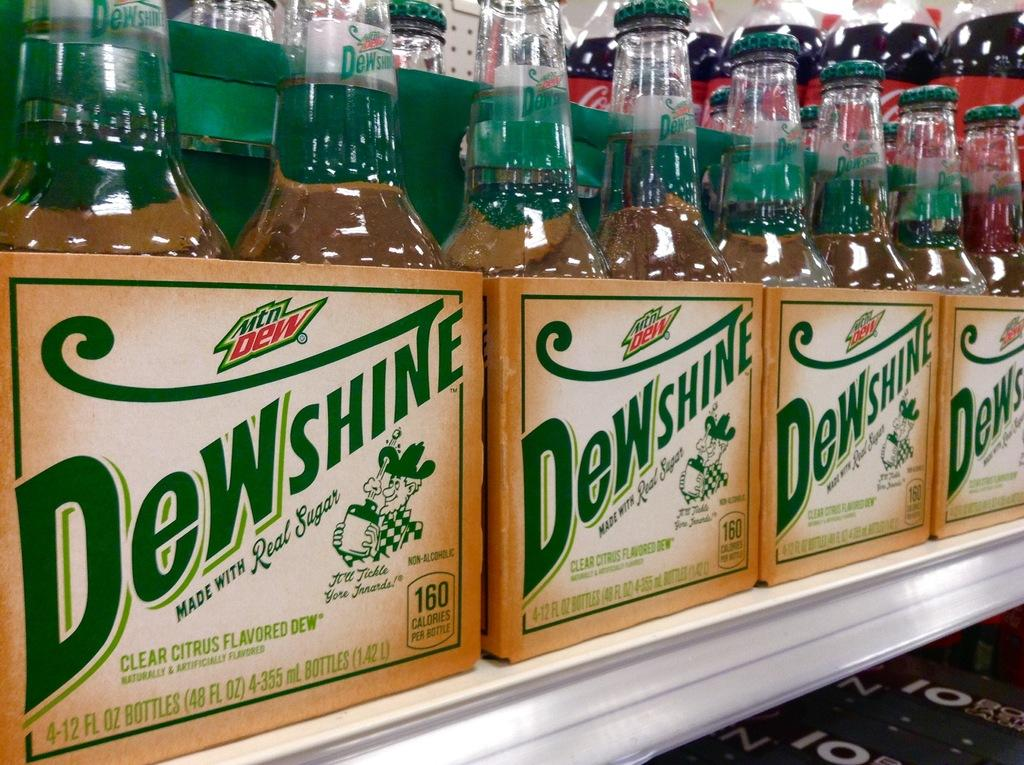<image>
Give a short and clear explanation of the subsequent image. Many boxes of Dew Shine beer by Mountain Dew. 